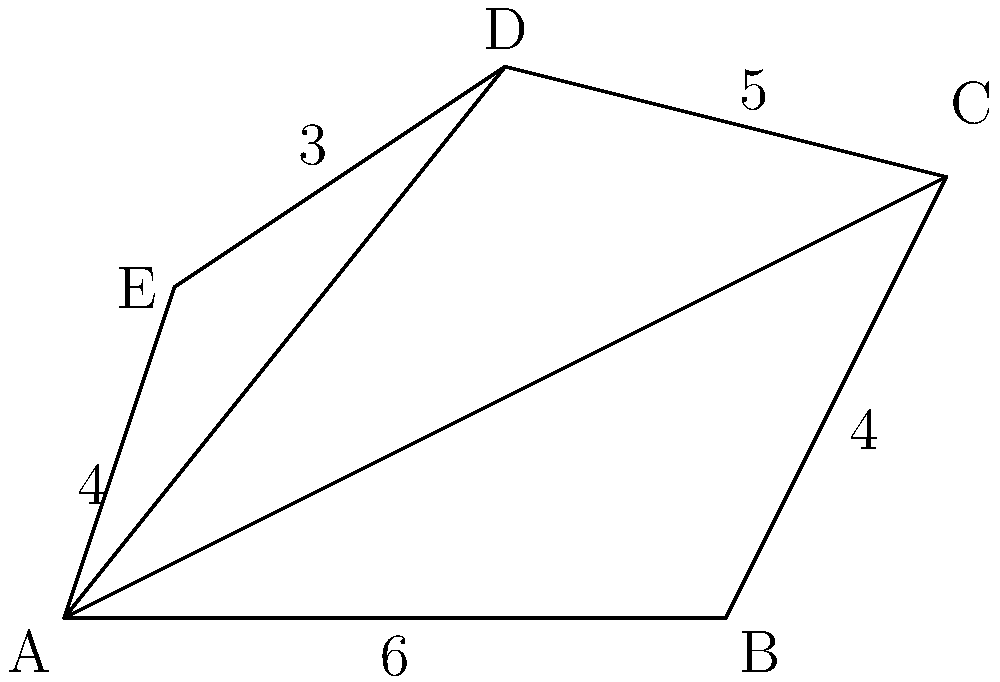As a fresco restorer, you're tasked with calculating the area of an irregularly shaped fresco to determine the amount of restoration materials needed. The fresco can be divided into three triangles as shown in the diagram. Given the dimensions provided, calculate the total area of the fresco in square meters. To calculate the area of the irregular fresco, we'll use the triangulation method:

1) Divide the fresco into three triangles: ABC, ACD, and ADE.

2) Calculate the area of each triangle using Heron's formula:
   $A = \sqrt{s(s-a)(s-b)(s-c)}$
   where $s = \frac{a+b+c}{2}$ (semi-perimeter) and $a$, $b$, $c$ are the side lengths.

3) Triangle ABC:
   $a = 6$, $b = 4$, $c = \sqrt{6^2 + 4^2} = \sqrt{52} = 7.21$ (Pythagorean theorem)
   $s = \frac{6 + 4 + 7.21}{2} = 8.61$
   $A_{ABC} = \sqrt{8.61(8.61-6)(8.61-4)(8.61-7.21)} = 12$ m²

4) Triangle ACD:
   $a = 7.21$, $b = 5$, $c = \sqrt{4^2 + 5^2} = \sqrt{41} = 6.40$
   $s = \frac{7.21 + 5 + 6.40}{2} = 9.31$
   $A_{ACD} = \sqrt{9.31(9.31-7.21)(9.31-5)(9.31-6.40)} = 16$ m²

5) Triangle ADE:
   $a = 4$, $b = 3$, $c = \sqrt{1^2 + 3^2} = \sqrt{10} = 3.16$
   $s = \frac{4 + 3 + 3.16}{2} = 5.08$
   $A_{ADE} = \sqrt{5.08(5.08-4)(5.08-3)(5.08-3.16)} = 5$ m²

6) Total area = $A_{ABC} + A_{ACD} + A_{ADE} = 12 + 16 + 5 = 33$ m²
Answer: 33 m² 